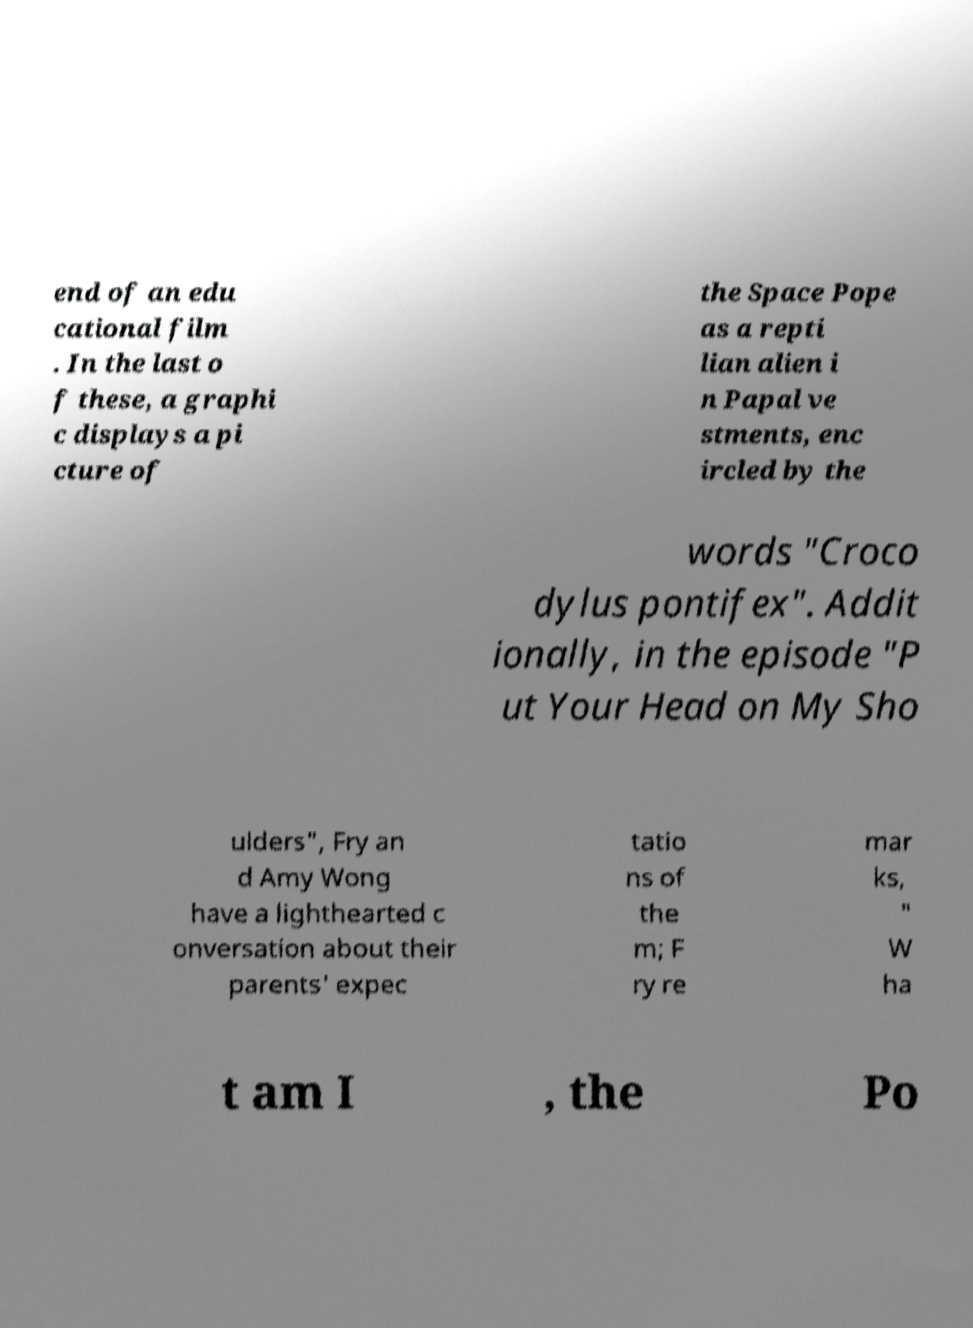Can you read and provide the text displayed in the image?This photo seems to have some interesting text. Can you extract and type it out for me? end of an edu cational film . In the last o f these, a graphi c displays a pi cture of the Space Pope as a repti lian alien i n Papal ve stments, enc ircled by the words "Croco dylus pontifex". Addit ionally, in the episode "P ut Your Head on My Sho ulders", Fry an d Amy Wong have a lighthearted c onversation about their parents' expec tatio ns of the m; F ry re mar ks, " W ha t am I , the Po 